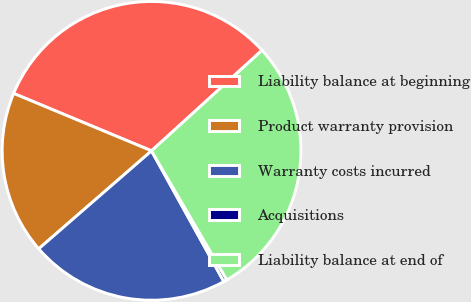<chart> <loc_0><loc_0><loc_500><loc_500><pie_chart><fcel>Liability balance at beginning<fcel>Product warranty provision<fcel>Warranty costs incurred<fcel>Acquisitions<fcel>Liability balance at end of<nl><fcel>31.97%<fcel>17.66%<fcel>21.66%<fcel>0.37%<fcel>28.34%<nl></chart> 